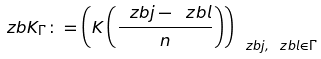Convert formula to latex. <formula><loc_0><loc_0><loc_500><loc_500>\ z b K _ { \Gamma } \colon = \left ( K \left ( \frac { \ z b j - \ z b l } { n } \right ) \right ) _ { \ z b j , \ z b l \in \Gamma }</formula> 